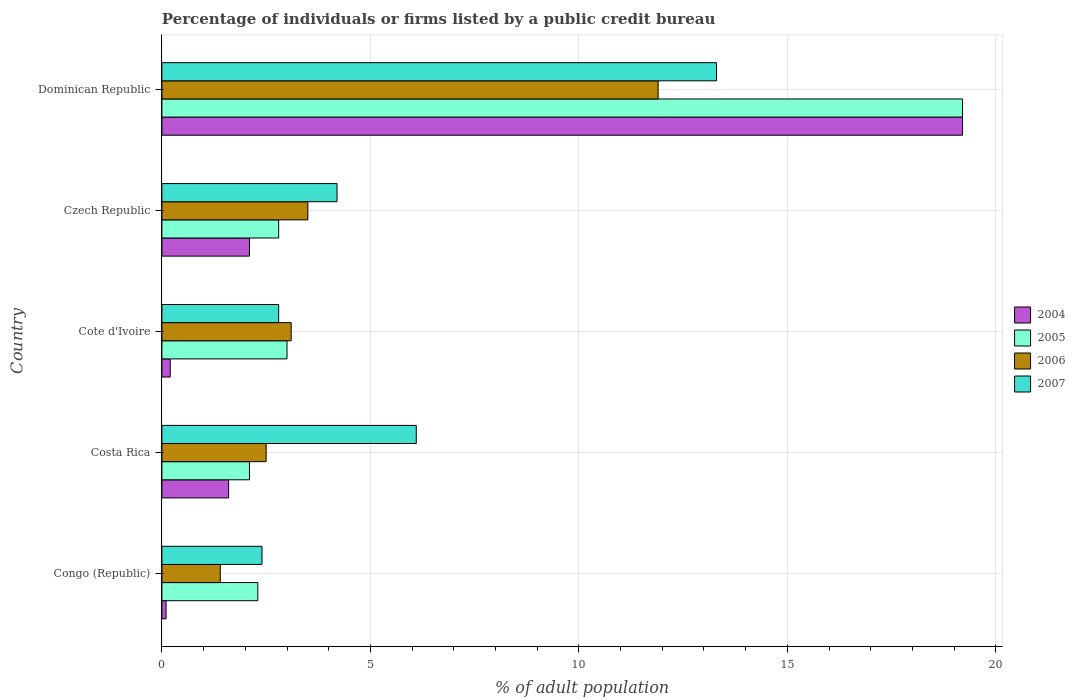Are the number of bars on each tick of the Y-axis equal?
Your answer should be compact. Yes. How many bars are there on the 1st tick from the top?
Provide a short and direct response. 4. What is the label of the 3rd group of bars from the top?
Provide a short and direct response. Cote d'Ivoire. In how many cases, is the number of bars for a given country not equal to the number of legend labels?
Your response must be concise. 0. Across all countries, what is the maximum percentage of population listed by a public credit bureau in 2007?
Keep it short and to the point. 13.3. Across all countries, what is the minimum percentage of population listed by a public credit bureau in 2004?
Your answer should be very brief. 0.1. In which country was the percentage of population listed by a public credit bureau in 2006 maximum?
Your response must be concise. Dominican Republic. What is the total percentage of population listed by a public credit bureau in 2007 in the graph?
Ensure brevity in your answer.  28.8. What is the difference between the percentage of population listed by a public credit bureau in 2006 in Costa Rica and that in Cote d'Ivoire?
Your answer should be compact. -0.6. What is the difference between the percentage of population listed by a public credit bureau in 2005 in Congo (Republic) and the percentage of population listed by a public credit bureau in 2004 in Cote d'Ivoire?
Your answer should be very brief. 2.1. What is the average percentage of population listed by a public credit bureau in 2007 per country?
Your answer should be very brief. 5.76. In how many countries, is the percentage of population listed by a public credit bureau in 2007 greater than 14 %?
Offer a very short reply. 0. What is the ratio of the percentage of population listed by a public credit bureau in 2006 in Congo (Republic) to that in Costa Rica?
Provide a succinct answer. 0.56. Is the percentage of population listed by a public credit bureau in 2005 in Congo (Republic) less than that in Cote d'Ivoire?
Give a very brief answer. Yes. What is the difference between the highest and the second highest percentage of population listed by a public credit bureau in 2004?
Provide a short and direct response. 17.1. What is the difference between the highest and the lowest percentage of population listed by a public credit bureau in 2005?
Your answer should be very brief. 17.1. In how many countries, is the percentage of population listed by a public credit bureau in 2007 greater than the average percentage of population listed by a public credit bureau in 2007 taken over all countries?
Your response must be concise. 2. What does the 3rd bar from the top in Cote d'Ivoire represents?
Keep it short and to the point. 2005. What does the 2nd bar from the bottom in Congo (Republic) represents?
Ensure brevity in your answer.  2005. How many bars are there?
Provide a succinct answer. 20. How are the legend labels stacked?
Offer a very short reply. Vertical. What is the title of the graph?
Make the answer very short. Percentage of individuals or firms listed by a public credit bureau. What is the label or title of the X-axis?
Ensure brevity in your answer.  % of adult population. What is the label or title of the Y-axis?
Your answer should be very brief. Country. What is the % of adult population of 2004 in Congo (Republic)?
Offer a very short reply. 0.1. What is the % of adult population in 2006 in Costa Rica?
Provide a short and direct response. 2.5. What is the % of adult population in 2005 in Cote d'Ivoire?
Give a very brief answer. 3. What is the % of adult population in 2006 in Cote d'Ivoire?
Make the answer very short. 3.1. What is the % of adult population in 2007 in Cote d'Ivoire?
Provide a short and direct response. 2.8. What is the % of adult population in 2005 in Czech Republic?
Make the answer very short. 2.8. What is the % of adult population in 2006 in Czech Republic?
Make the answer very short. 3.5. What is the % of adult population in 2007 in Czech Republic?
Provide a short and direct response. 4.2. What is the % of adult population of 2006 in Dominican Republic?
Make the answer very short. 11.9. What is the % of adult population of 2007 in Dominican Republic?
Provide a succinct answer. 13.3. Across all countries, what is the maximum % of adult population of 2006?
Keep it short and to the point. 11.9. Across all countries, what is the maximum % of adult population of 2007?
Keep it short and to the point. 13.3. Across all countries, what is the minimum % of adult population in 2005?
Your answer should be compact. 2.1. What is the total % of adult population of 2004 in the graph?
Your response must be concise. 23.2. What is the total % of adult population of 2005 in the graph?
Make the answer very short. 29.4. What is the total % of adult population of 2006 in the graph?
Provide a short and direct response. 22.4. What is the total % of adult population in 2007 in the graph?
Give a very brief answer. 28.8. What is the difference between the % of adult population of 2005 in Congo (Republic) and that in Costa Rica?
Provide a succinct answer. 0.2. What is the difference between the % of adult population in 2005 in Congo (Republic) and that in Cote d'Ivoire?
Ensure brevity in your answer.  -0.7. What is the difference between the % of adult population in 2005 in Congo (Republic) and that in Czech Republic?
Ensure brevity in your answer.  -0.5. What is the difference between the % of adult population of 2004 in Congo (Republic) and that in Dominican Republic?
Your answer should be very brief. -19.1. What is the difference between the % of adult population in 2005 in Congo (Republic) and that in Dominican Republic?
Provide a succinct answer. -16.9. What is the difference between the % of adult population in 2007 in Congo (Republic) and that in Dominican Republic?
Offer a very short reply. -10.9. What is the difference between the % of adult population in 2005 in Costa Rica and that in Cote d'Ivoire?
Provide a succinct answer. -0.9. What is the difference between the % of adult population in 2004 in Costa Rica and that in Czech Republic?
Offer a very short reply. -0.5. What is the difference between the % of adult population in 2005 in Costa Rica and that in Czech Republic?
Your answer should be very brief. -0.7. What is the difference between the % of adult population in 2007 in Costa Rica and that in Czech Republic?
Offer a very short reply. 1.9. What is the difference between the % of adult population in 2004 in Costa Rica and that in Dominican Republic?
Ensure brevity in your answer.  -17.6. What is the difference between the % of adult population of 2005 in Costa Rica and that in Dominican Republic?
Offer a terse response. -17.1. What is the difference between the % of adult population of 2006 in Costa Rica and that in Dominican Republic?
Your response must be concise. -9.4. What is the difference between the % of adult population of 2004 in Cote d'Ivoire and that in Czech Republic?
Your answer should be compact. -1.9. What is the difference between the % of adult population in 2005 in Cote d'Ivoire and that in Czech Republic?
Your answer should be very brief. 0.2. What is the difference between the % of adult population in 2004 in Cote d'Ivoire and that in Dominican Republic?
Keep it short and to the point. -19. What is the difference between the % of adult population in 2005 in Cote d'Ivoire and that in Dominican Republic?
Give a very brief answer. -16.2. What is the difference between the % of adult population in 2006 in Cote d'Ivoire and that in Dominican Republic?
Make the answer very short. -8.8. What is the difference between the % of adult population of 2004 in Czech Republic and that in Dominican Republic?
Provide a short and direct response. -17.1. What is the difference between the % of adult population of 2005 in Czech Republic and that in Dominican Republic?
Give a very brief answer. -16.4. What is the difference between the % of adult population in 2006 in Czech Republic and that in Dominican Republic?
Offer a terse response. -8.4. What is the difference between the % of adult population of 2004 in Congo (Republic) and the % of adult population of 2006 in Costa Rica?
Your response must be concise. -2.4. What is the difference between the % of adult population in 2004 in Congo (Republic) and the % of adult population in 2007 in Costa Rica?
Offer a terse response. -6. What is the difference between the % of adult population of 2005 in Congo (Republic) and the % of adult population of 2006 in Costa Rica?
Your answer should be very brief. -0.2. What is the difference between the % of adult population of 2005 in Congo (Republic) and the % of adult population of 2007 in Costa Rica?
Your answer should be very brief. -3.8. What is the difference between the % of adult population of 2006 in Congo (Republic) and the % of adult population of 2007 in Costa Rica?
Your answer should be compact. -4.7. What is the difference between the % of adult population of 2004 in Congo (Republic) and the % of adult population of 2005 in Cote d'Ivoire?
Provide a succinct answer. -2.9. What is the difference between the % of adult population of 2004 in Congo (Republic) and the % of adult population of 2007 in Cote d'Ivoire?
Keep it short and to the point. -2.7. What is the difference between the % of adult population in 2005 in Congo (Republic) and the % of adult population in 2006 in Cote d'Ivoire?
Your response must be concise. -0.8. What is the difference between the % of adult population of 2005 in Congo (Republic) and the % of adult population of 2007 in Cote d'Ivoire?
Make the answer very short. -0.5. What is the difference between the % of adult population of 2006 in Congo (Republic) and the % of adult population of 2007 in Cote d'Ivoire?
Give a very brief answer. -1.4. What is the difference between the % of adult population of 2004 in Congo (Republic) and the % of adult population of 2005 in Czech Republic?
Your answer should be very brief. -2.7. What is the difference between the % of adult population in 2004 in Congo (Republic) and the % of adult population in 2006 in Czech Republic?
Provide a succinct answer. -3.4. What is the difference between the % of adult population in 2004 in Congo (Republic) and the % of adult population in 2007 in Czech Republic?
Keep it short and to the point. -4.1. What is the difference between the % of adult population of 2005 in Congo (Republic) and the % of adult population of 2006 in Czech Republic?
Provide a short and direct response. -1.2. What is the difference between the % of adult population in 2005 in Congo (Republic) and the % of adult population in 2007 in Czech Republic?
Give a very brief answer. -1.9. What is the difference between the % of adult population of 2004 in Congo (Republic) and the % of adult population of 2005 in Dominican Republic?
Your answer should be very brief. -19.1. What is the difference between the % of adult population of 2004 in Congo (Republic) and the % of adult population of 2006 in Dominican Republic?
Ensure brevity in your answer.  -11.8. What is the difference between the % of adult population in 2004 in Congo (Republic) and the % of adult population in 2007 in Dominican Republic?
Keep it short and to the point. -13.2. What is the difference between the % of adult population in 2006 in Congo (Republic) and the % of adult population in 2007 in Dominican Republic?
Your answer should be very brief. -11.9. What is the difference between the % of adult population in 2004 in Costa Rica and the % of adult population in 2005 in Cote d'Ivoire?
Give a very brief answer. -1.4. What is the difference between the % of adult population of 2004 in Costa Rica and the % of adult population of 2006 in Cote d'Ivoire?
Provide a short and direct response. -1.5. What is the difference between the % of adult population in 2004 in Costa Rica and the % of adult population in 2007 in Cote d'Ivoire?
Provide a short and direct response. -1.2. What is the difference between the % of adult population of 2005 in Costa Rica and the % of adult population of 2007 in Cote d'Ivoire?
Ensure brevity in your answer.  -0.7. What is the difference between the % of adult population of 2006 in Costa Rica and the % of adult population of 2007 in Cote d'Ivoire?
Offer a terse response. -0.3. What is the difference between the % of adult population of 2004 in Costa Rica and the % of adult population of 2006 in Czech Republic?
Your response must be concise. -1.9. What is the difference between the % of adult population of 2004 in Costa Rica and the % of adult population of 2007 in Czech Republic?
Offer a terse response. -2.6. What is the difference between the % of adult population in 2005 in Costa Rica and the % of adult population in 2006 in Czech Republic?
Keep it short and to the point. -1.4. What is the difference between the % of adult population in 2005 in Costa Rica and the % of adult population in 2007 in Czech Republic?
Give a very brief answer. -2.1. What is the difference between the % of adult population of 2004 in Costa Rica and the % of adult population of 2005 in Dominican Republic?
Ensure brevity in your answer.  -17.6. What is the difference between the % of adult population in 2005 in Costa Rica and the % of adult population in 2006 in Dominican Republic?
Provide a succinct answer. -9.8. What is the difference between the % of adult population in 2005 in Costa Rica and the % of adult population in 2007 in Dominican Republic?
Ensure brevity in your answer.  -11.2. What is the difference between the % of adult population in 2006 in Cote d'Ivoire and the % of adult population in 2007 in Czech Republic?
Offer a terse response. -1.1. What is the difference between the % of adult population of 2004 in Cote d'Ivoire and the % of adult population of 2006 in Dominican Republic?
Keep it short and to the point. -11.7. What is the difference between the % of adult population in 2006 in Cote d'Ivoire and the % of adult population in 2007 in Dominican Republic?
Keep it short and to the point. -10.2. What is the difference between the % of adult population of 2004 in Czech Republic and the % of adult population of 2005 in Dominican Republic?
Your response must be concise. -17.1. What is the difference between the % of adult population of 2004 in Czech Republic and the % of adult population of 2006 in Dominican Republic?
Make the answer very short. -9.8. What is the difference between the % of adult population of 2004 in Czech Republic and the % of adult population of 2007 in Dominican Republic?
Your answer should be compact. -11.2. What is the difference between the % of adult population of 2005 in Czech Republic and the % of adult population of 2006 in Dominican Republic?
Keep it short and to the point. -9.1. What is the difference between the % of adult population of 2005 in Czech Republic and the % of adult population of 2007 in Dominican Republic?
Provide a short and direct response. -10.5. What is the average % of adult population in 2004 per country?
Your response must be concise. 4.64. What is the average % of adult population in 2005 per country?
Offer a terse response. 5.88. What is the average % of adult population of 2006 per country?
Give a very brief answer. 4.48. What is the average % of adult population of 2007 per country?
Give a very brief answer. 5.76. What is the difference between the % of adult population of 2004 and % of adult population of 2007 in Congo (Republic)?
Give a very brief answer. -2.3. What is the difference between the % of adult population of 2006 and % of adult population of 2007 in Congo (Republic)?
Make the answer very short. -1. What is the difference between the % of adult population in 2004 and % of adult population in 2005 in Costa Rica?
Give a very brief answer. -0.5. What is the difference between the % of adult population of 2004 and % of adult population of 2007 in Costa Rica?
Keep it short and to the point. -4.5. What is the difference between the % of adult population in 2005 and % of adult population in 2007 in Costa Rica?
Give a very brief answer. -4. What is the difference between the % of adult population in 2006 and % of adult population in 2007 in Costa Rica?
Offer a terse response. -3.6. What is the difference between the % of adult population of 2004 and % of adult population of 2007 in Cote d'Ivoire?
Ensure brevity in your answer.  -2.6. What is the difference between the % of adult population of 2006 and % of adult population of 2007 in Cote d'Ivoire?
Keep it short and to the point. 0.3. What is the difference between the % of adult population in 2004 and % of adult population in 2005 in Czech Republic?
Your answer should be compact. -0.7. What is the difference between the % of adult population of 2004 and % of adult population of 2007 in Czech Republic?
Keep it short and to the point. -2.1. What is the difference between the % of adult population of 2004 and % of adult population of 2006 in Dominican Republic?
Your answer should be compact. 7.3. What is the difference between the % of adult population in 2005 and % of adult population in 2006 in Dominican Republic?
Offer a very short reply. 7.3. What is the ratio of the % of adult population of 2004 in Congo (Republic) to that in Costa Rica?
Your answer should be compact. 0.06. What is the ratio of the % of adult population of 2005 in Congo (Republic) to that in Costa Rica?
Offer a terse response. 1.1. What is the ratio of the % of adult population of 2006 in Congo (Republic) to that in Costa Rica?
Your answer should be very brief. 0.56. What is the ratio of the % of adult population in 2007 in Congo (Republic) to that in Costa Rica?
Ensure brevity in your answer.  0.39. What is the ratio of the % of adult population in 2005 in Congo (Republic) to that in Cote d'Ivoire?
Offer a very short reply. 0.77. What is the ratio of the % of adult population in 2006 in Congo (Republic) to that in Cote d'Ivoire?
Offer a terse response. 0.45. What is the ratio of the % of adult population in 2004 in Congo (Republic) to that in Czech Republic?
Your answer should be very brief. 0.05. What is the ratio of the % of adult population of 2005 in Congo (Republic) to that in Czech Republic?
Keep it short and to the point. 0.82. What is the ratio of the % of adult population in 2004 in Congo (Republic) to that in Dominican Republic?
Offer a very short reply. 0.01. What is the ratio of the % of adult population of 2005 in Congo (Republic) to that in Dominican Republic?
Make the answer very short. 0.12. What is the ratio of the % of adult population in 2006 in Congo (Republic) to that in Dominican Republic?
Offer a terse response. 0.12. What is the ratio of the % of adult population in 2007 in Congo (Republic) to that in Dominican Republic?
Offer a terse response. 0.18. What is the ratio of the % of adult population of 2004 in Costa Rica to that in Cote d'Ivoire?
Your answer should be compact. 8. What is the ratio of the % of adult population of 2005 in Costa Rica to that in Cote d'Ivoire?
Provide a succinct answer. 0.7. What is the ratio of the % of adult population of 2006 in Costa Rica to that in Cote d'Ivoire?
Provide a succinct answer. 0.81. What is the ratio of the % of adult population of 2007 in Costa Rica to that in Cote d'Ivoire?
Provide a succinct answer. 2.18. What is the ratio of the % of adult population of 2004 in Costa Rica to that in Czech Republic?
Make the answer very short. 0.76. What is the ratio of the % of adult population of 2005 in Costa Rica to that in Czech Republic?
Your answer should be very brief. 0.75. What is the ratio of the % of adult population of 2007 in Costa Rica to that in Czech Republic?
Give a very brief answer. 1.45. What is the ratio of the % of adult population in 2004 in Costa Rica to that in Dominican Republic?
Offer a very short reply. 0.08. What is the ratio of the % of adult population of 2005 in Costa Rica to that in Dominican Republic?
Offer a terse response. 0.11. What is the ratio of the % of adult population of 2006 in Costa Rica to that in Dominican Republic?
Offer a terse response. 0.21. What is the ratio of the % of adult population in 2007 in Costa Rica to that in Dominican Republic?
Your response must be concise. 0.46. What is the ratio of the % of adult population in 2004 in Cote d'Ivoire to that in Czech Republic?
Provide a short and direct response. 0.1. What is the ratio of the % of adult population in 2005 in Cote d'Ivoire to that in Czech Republic?
Give a very brief answer. 1.07. What is the ratio of the % of adult population in 2006 in Cote d'Ivoire to that in Czech Republic?
Keep it short and to the point. 0.89. What is the ratio of the % of adult population of 2007 in Cote d'Ivoire to that in Czech Republic?
Your answer should be compact. 0.67. What is the ratio of the % of adult population of 2004 in Cote d'Ivoire to that in Dominican Republic?
Make the answer very short. 0.01. What is the ratio of the % of adult population of 2005 in Cote d'Ivoire to that in Dominican Republic?
Offer a terse response. 0.16. What is the ratio of the % of adult population in 2006 in Cote d'Ivoire to that in Dominican Republic?
Provide a succinct answer. 0.26. What is the ratio of the % of adult population of 2007 in Cote d'Ivoire to that in Dominican Republic?
Your answer should be very brief. 0.21. What is the ratio of the % of adult population of 2004 in Czech Republic to that in Dominican Republic?
Your answer should be very brief. 0.11. What is the ratio of the % of adult population of 2005 in Czech Republic to that in Dominican Republic?
Offer a terse response. 0.15. What is the ratio of the % of adult population in 2006 in Czech Republic to that in Dominican Republic?
Ensure brevity in your answer.  0.29. What is the ratio of the % of adult population in 2007 in Czech Republic to that in Dominican Republic?
Make the answer very short. 0.32. What is the difference between the highest and the second highest % of adult population in 2004?
Your answer should be very brief. 17.1. What is the difference between the highest and the second highest % of adult population in 2006?
Offer a terse response. 8.4. What is the difference between the highest and the lowest % of adult population of 2005?
Keep it short and to the point. 17.1. 